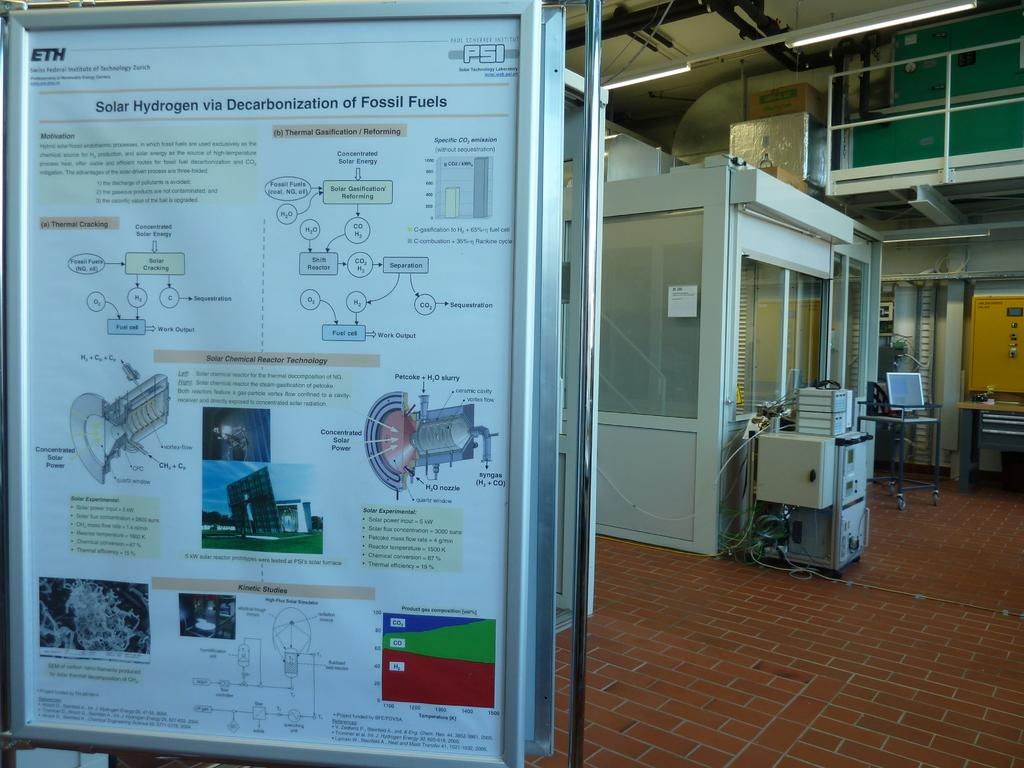Provide a one-sentence caption for the provided image. A scientific poster explains the concept and process behind Solar Hydrogen. 